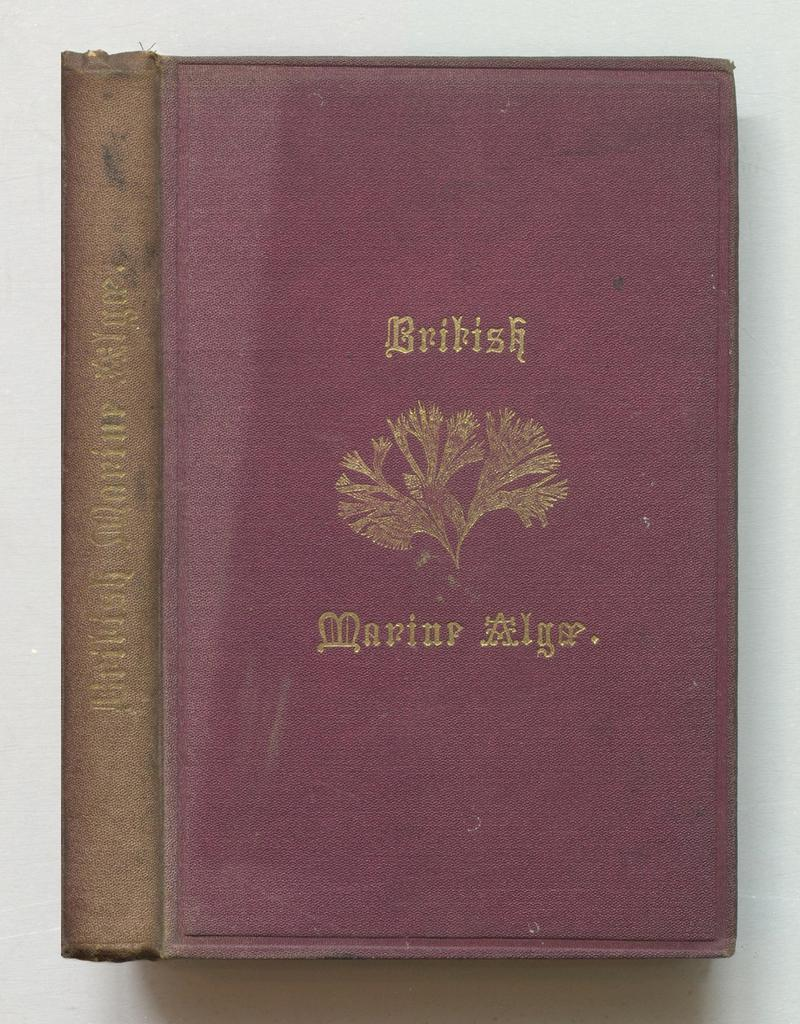<image>
Provide a brief description of the given image. A book titled "British Marine Alga" that is red and brown. 